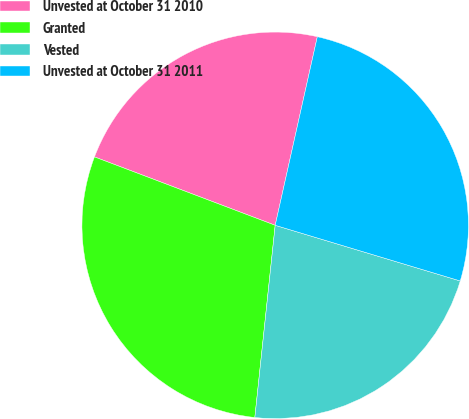Convert chart. <chart><loc_0><loc_0><loc_500><loc_500><pie_chart><fcel>Unvested at October 31 2010<fcel>Granted<fcel>Vested<fcel>Unvested at October 31 2011<nl><fcel>22.74%<fcel>29.08%<fcel>22.03%<fcel>26.15%<nl></chart> 